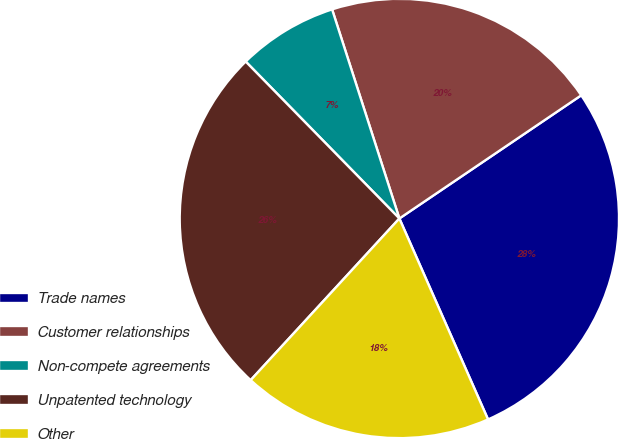Convert chart to OTSL. <chart><loc_0><loc_0><loc_500><loc_500><pie_chart><fcel>Trade names<fcel>Customer relationships<fcel>Non-compete agreements<fcel>Unpatented technology<fcel>Other<nl><fcel>27.86%<fcel>20.48%<fcel>7.38%<fcel>25.83%<fcel>18.45%<nl></chart> 